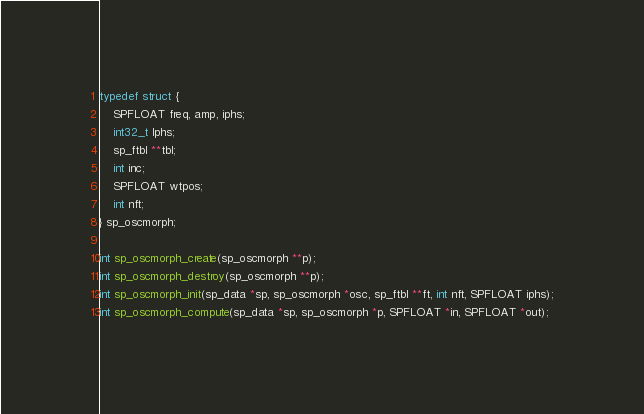Convert code to text. <code><loc_0><loc_0><loc_500><loc_500><_C_>typedef struct {
    SPFLOAT freq, amp, iphs;
    int32_t lphs;
    sp_ftbl **tbl;
    int inc;
    SPFLOAT wtpos;
    int nft;
} sp_oscmorph;

int sp_oscmorph_create(sp_oscmorph **p);
int sp_oscmorph_destroy(sp_oscmorph **p);
int sp_oscmorph_init(sp_data *sp, sp_oscmorph *osc, sp_ftbl **ft, int nft, SPFLOAT iphs);
int sp_oscmorph_compute(sp_data *sp, sp_oscmorph *p, SPFLOAT *in, SPFLOAT *out);
</code> 